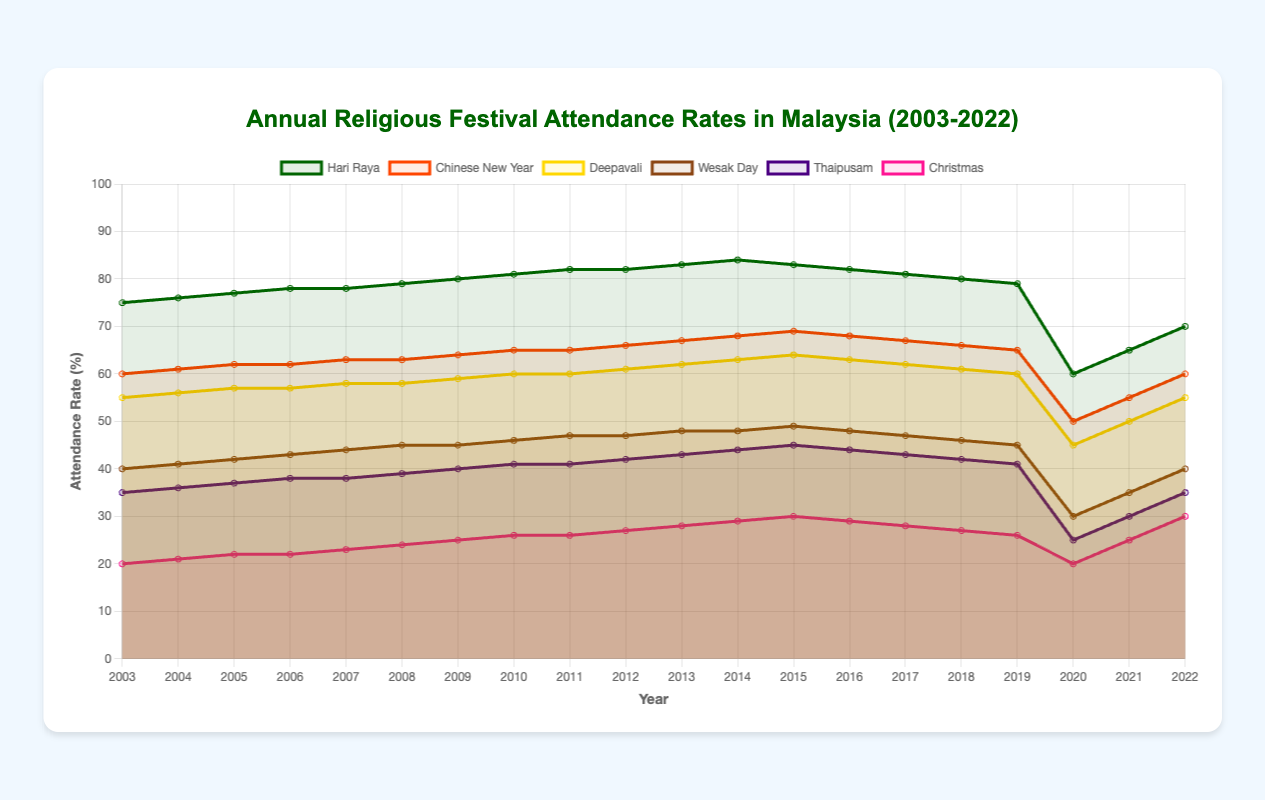What was the attendance rate for Hari Raya in 2010? Look at the point corresponding to 2010 on the 'Hari Raya' line in the graph and read its value.
Answer: 81 Between which two years did the attendance rate for Thaipusam have the steepest decline? Identify the two years on the 'Thaipusam' line where the drop between consecutive years is visually the greatest.
Answer: 2019-2020 Which festival had the lowest attendance rate in 2022? Compare the endpoint values for all six lines representing the festivals at the year 2022.
Answer: Wesak Day What's the average attendance rate for Hari Raya from 2018 to 2022? Add the values for 2018, 2019, 2020, 2021, and 2022 on the 'Hari Raya' line and divide by 5.
Answer: (80 + 79 + 60 + 65 + 70) / 5 = 70.8 Which two festivals had the same attendance rate in 2017, and what was the rate? Look at the intersection points in 2017 on all lines and find where two rates are the same.
Answer: Chinese New Year and Deepavali, 67 How did attendance rates for Christmas change between 2019 and 2020? Find the Christmas rate in 2019 and 2020, subtract to see the difference.
Answer: 26 to 20, decreased by 6 Which festival showed a recovery in attendance rate from 2020 to 2021, and by how much? Compare the values for 2020 and 2021 for each festival and identify which one increased.
Answer: Hari Raya, increased by 5 What is the difference between the highest and the lowest attendance rates for the entire period? Identify the highest and lowest points on the graph and subtract the lowest from the highest.
Answer: 84 (Hari Raya in 2014) - 20 (Christmas in 2003, 2020) = 64 How many festivals had an attendance rate above 60% in 2015? Count the lines that cross above the 60% line in the year 2015.
Answer: 3 (Hari Raya, Chinese New Year, Deepavali) In which year did the attendance rate for Wesak Day hit its peak? Locate the highest point on the 'Wesak Day' line and read the corresponding year.
Answer: 2015 